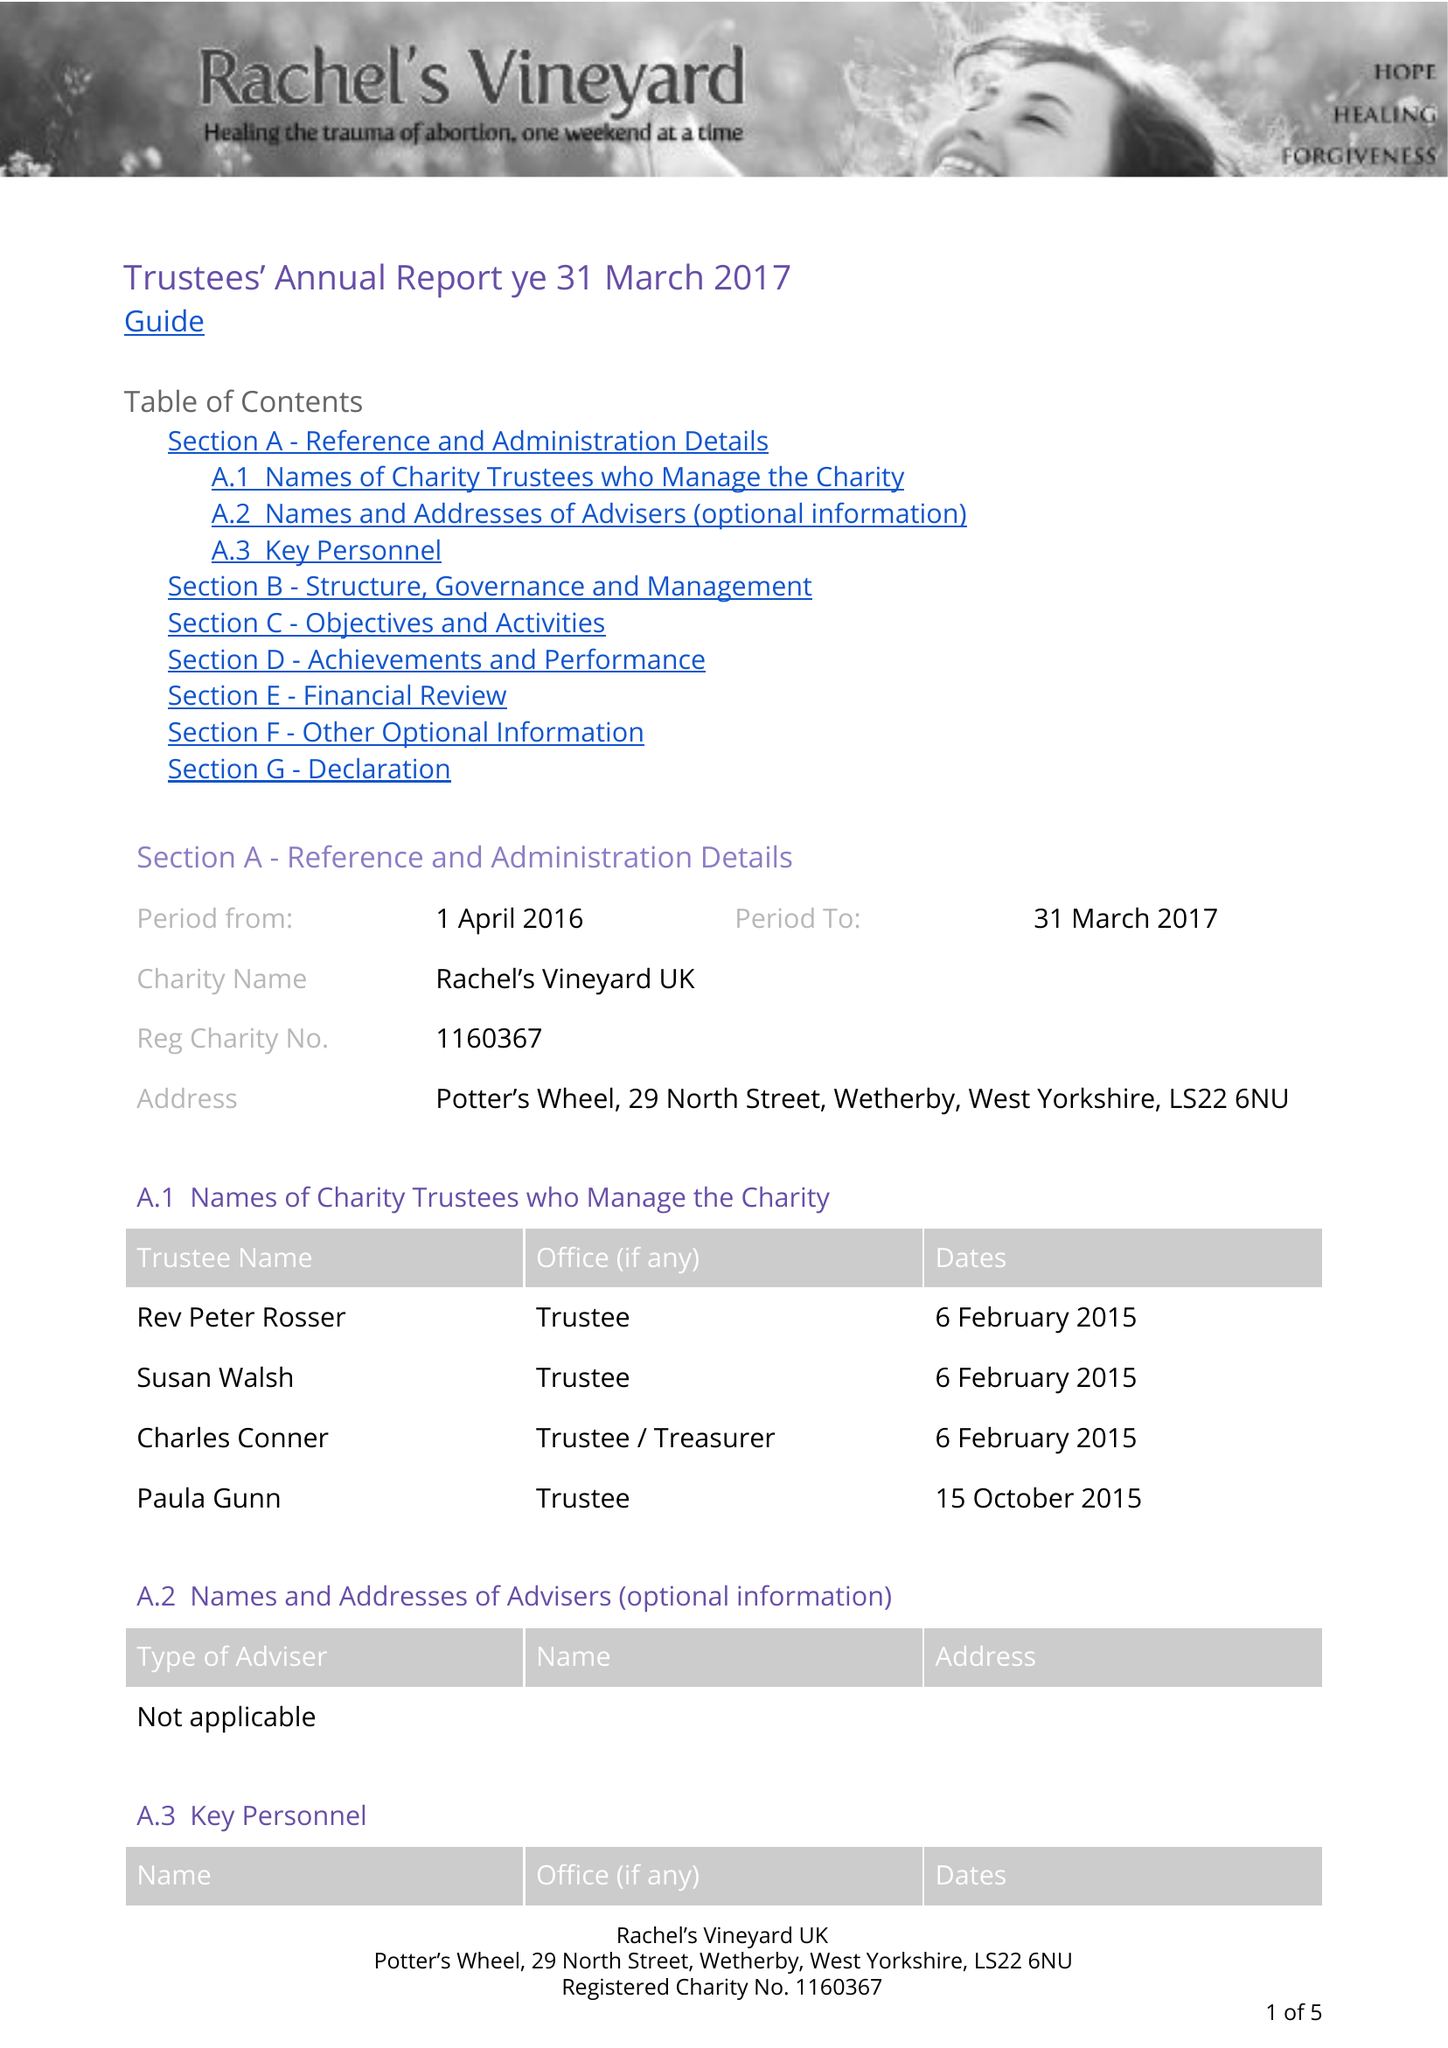What is the value for the spending_annually_in_british_pounds?
Answer the question using a single word or phrase. 10598.00 